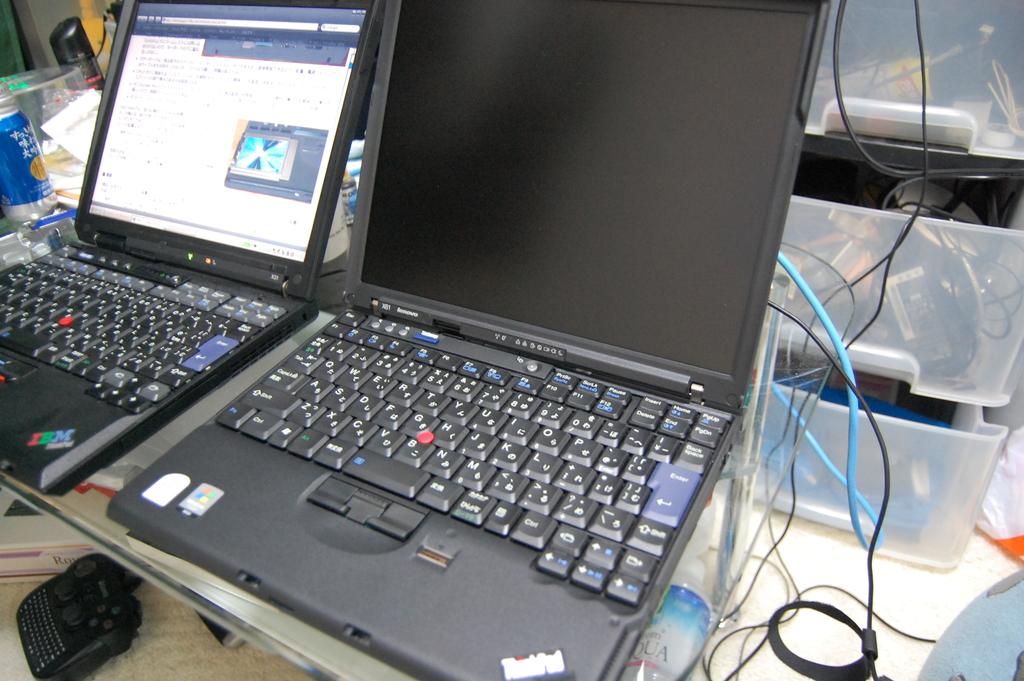What does the sticker on the left laptop say?
Offer a very short reply. Ibm. What brand is the laptop on the left?
Your response must be concise. Ibm. 